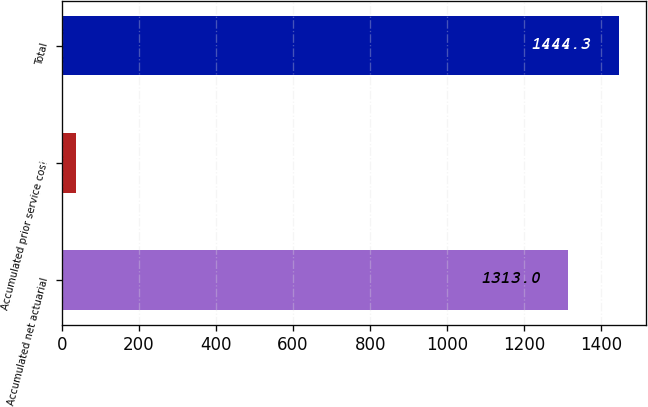Convert chart. <chart><loc_0><loc_0><loc_500><loc_500><bar_chart><fcel>Accumulated net actuarial<fcel>Accumulated prior service cost<fcel>Total<nl><fcel>1313<fcel>37<fcel>1444.3<nl></chart> 